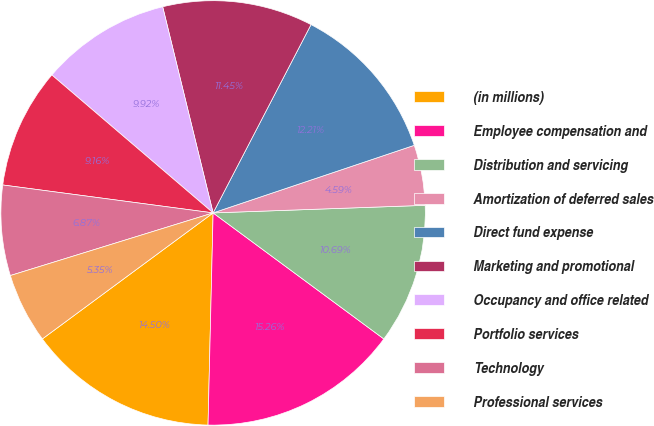Convert chart. <chart><loc_0><loc_0><loc_500><loc_500><pie_chart><fcel>(in millions)<fcel>Employee compensation and<fcel>Distribution and servicing<fcel>Amortization of deferred sales<fcel>Direct fund expense<fcel>Marketing and promotional<fcel>Occupancy and office related<fcel>Portfolio services<fcel>Technology<fcel>Professional services<nl><fcel>14.5%<fcel>15.26%<fcel>10.69%<fcel>4.59%<fcel>12.21%<fcel>11.45%<fcel>9.92%<fcel>9.16%<fcel>6.87%<fcel>5.35%<nl></chart> 